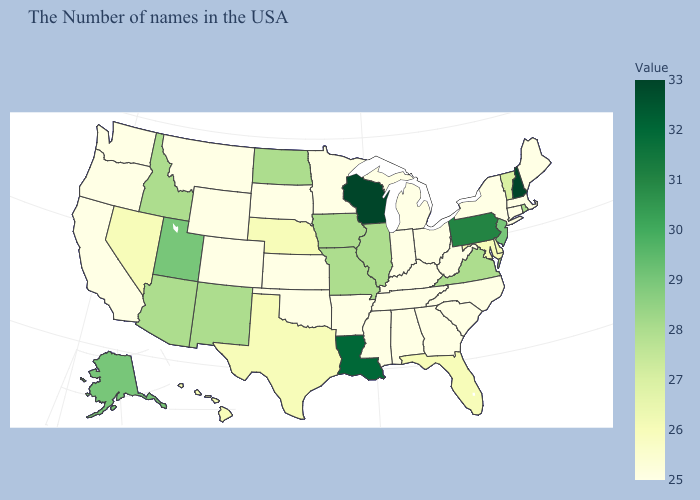Does Wisconsin have the lowest value in the USA?
Keep it brief. No. Does Wisconsin have the highest value in the MidWest?
Write a very short answer. Yes. Which states have the lowest value in the USA?
Write a very short answer. Maine, Massachusetts, Connecticut, New York, North Carolina, South Carolina, West Virginia, Ohio, Georgia, Michigan, Kentucky, Indiana, Alabama, Tennessee, Mississippi, Arkansas, Minnesota, Kansas, Oklahoma, South Dakota, Wyoming, Colorado, Montana, California, Washington, Oregon. Does Missouri have a lower value than Louisiana?
Short answer required. Yes. Does New Hampshire have the highest value in the Northeast?
Answer briefly. Yes. Does Kansas have a lower value than Maryland?
Concise answer only. Yes. 